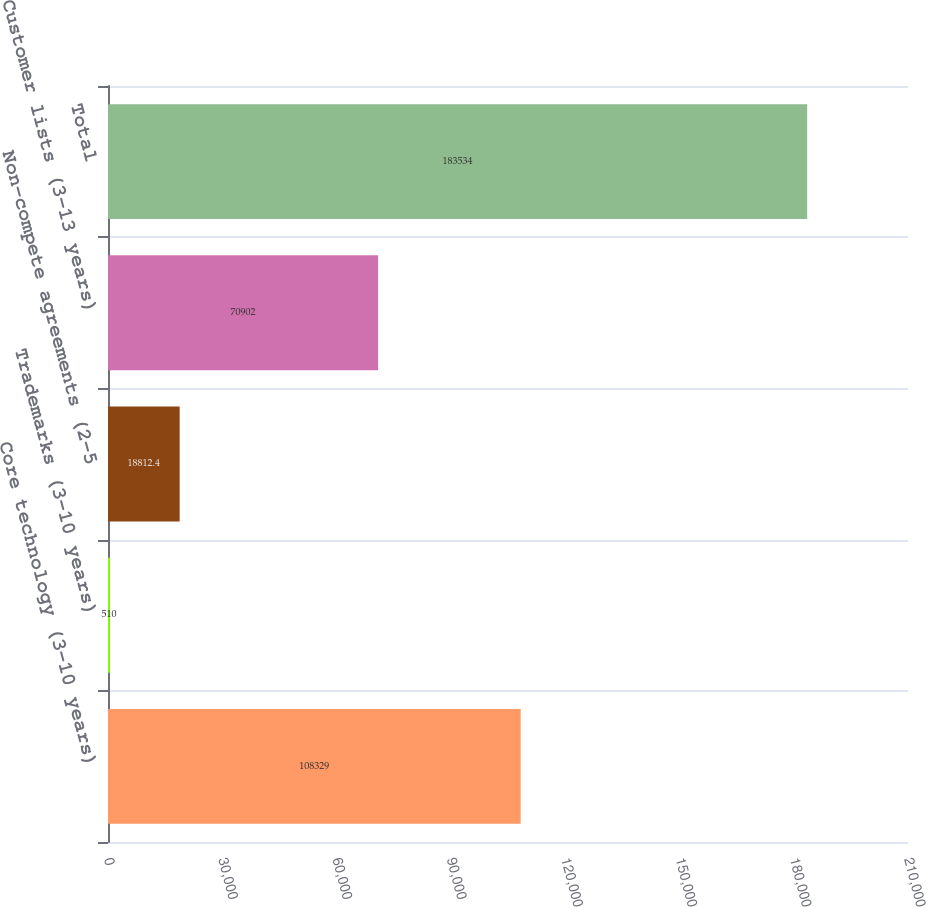Convert chart. <chart><loc_0><loc_0><loc_500><loc_500><bar_chart><fcel>Core technology (3-10 years)<fcel>Trademarks (3-10 years)<fcel>Non-compete agreements (2-5<fcel>Customer lists (3-13 years)<fcel>Total<nl><fcel>108329<fcel>510<fcel>18812.4<fcel>70902<fcel>183534<nl></chart> 